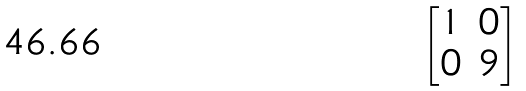<formula> <loc_0><loc_0><loc_500><loc_500>\begin{bmatrix} 1 & 0 \\ 0 & 9 \end{bmatrix}</formula> 